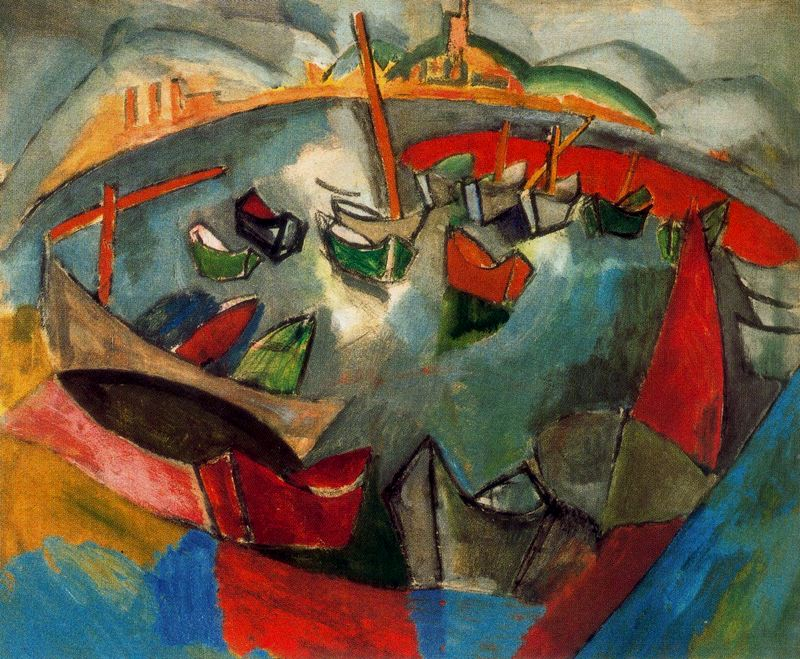How does the artist use shape and form in this painting? The artist uses exaggerated and distorted forms to create a visual flux that mirrors the ceaseless movement and chaos of a busy harbor. The boats are not depicted realistically but instead blend into each other, their forms simplified and abstracted to capture the essence of motion and overlap in the crowded space. 